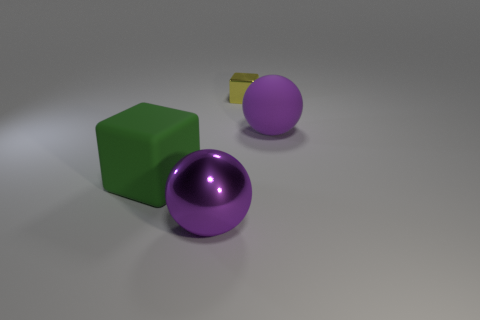Subtract all yellow cubes. How many cubes are left? 1 Add 3 small metal cubes. How many objects exist? 7 Subtract all green things. Subtract all large purple balls. How many objects are left? 1 Add 3 big objects. How many big objects are left? 6 Add 1 small red shiny objects. How many small red shiny objects exist? 1 Subtract 2 purple spheres. How many objects are left? 2 